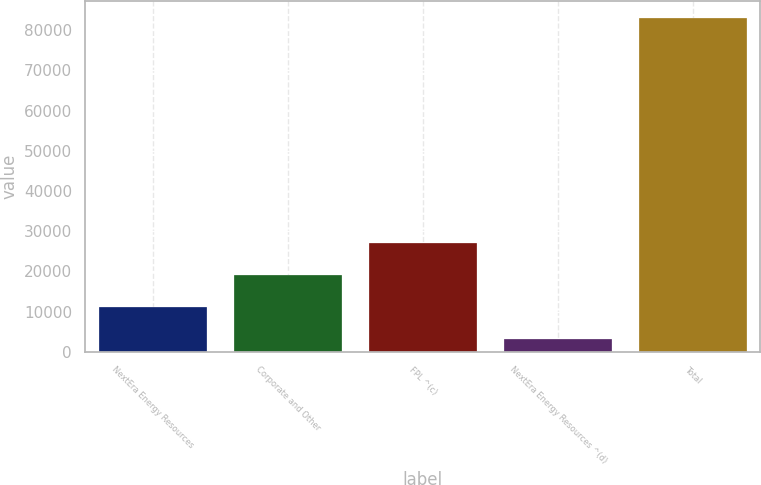<chart> <loc_0><loc_0><loc_500><loc_500><bar_chart><fcel>NextEra Energy Resources<fcel>Corporate and Other<fcel>FPL ^(c)<fcel>NextEra Energy Resources ^(d)<fcel>Total<nl><fcel>11088.5<fcel>19087<fcel>27085.5<fcel>3090<fcel>83075<nl></chart> 